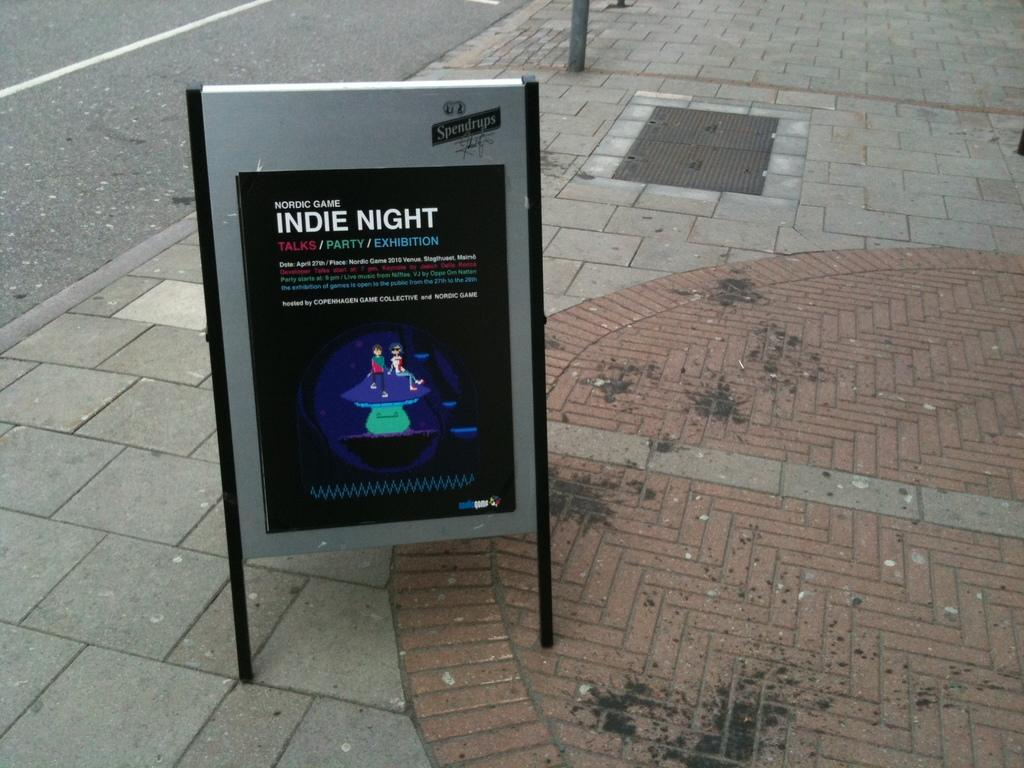<image>
Describe the image concisely. A poster on display with Indie night being promoted. 